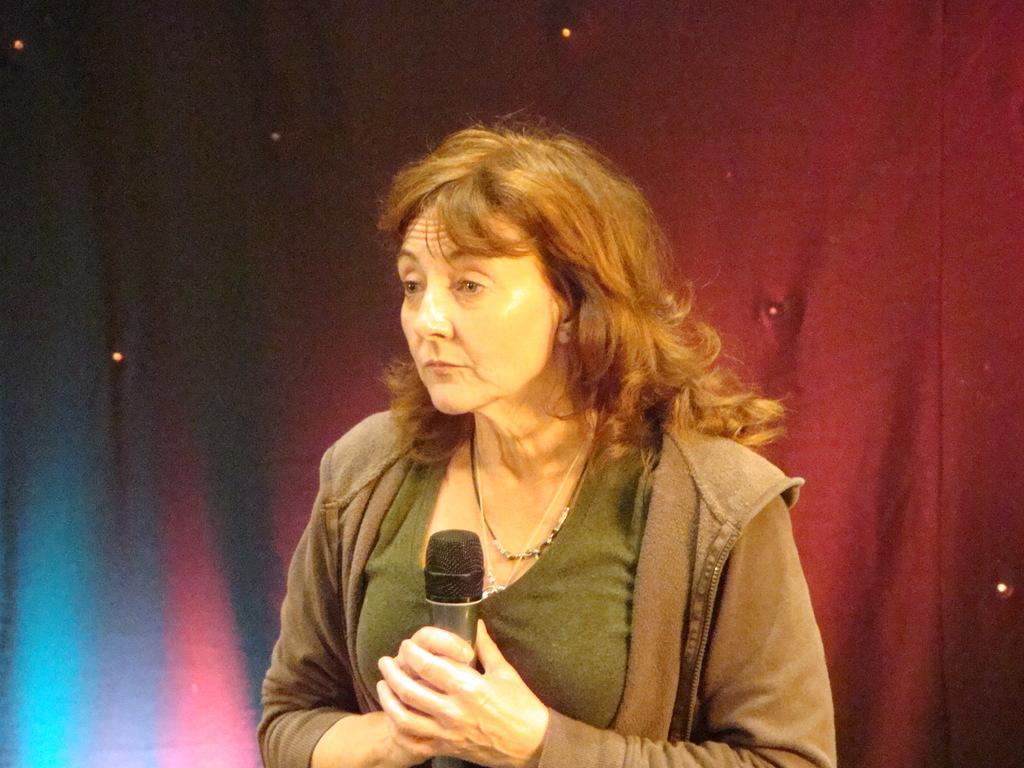Describe this image in one or two sentences. In this image, In the middle there is a woman she is standing and holding a microphone which is in black color, In the background there is a red color curtain. 